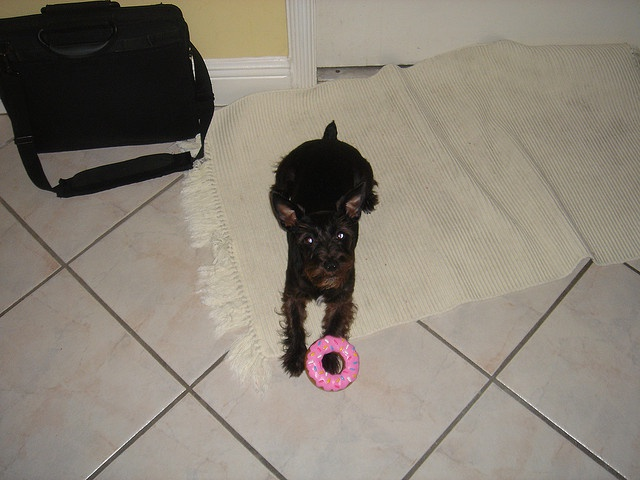Describe the objects in this image and their specific colors. I can see handbag in gray, black, and darkgray tones, dog in gray, black, maroon, and darkgray tones, and donut in gray, violet, lightpink, and black tones in this image. 